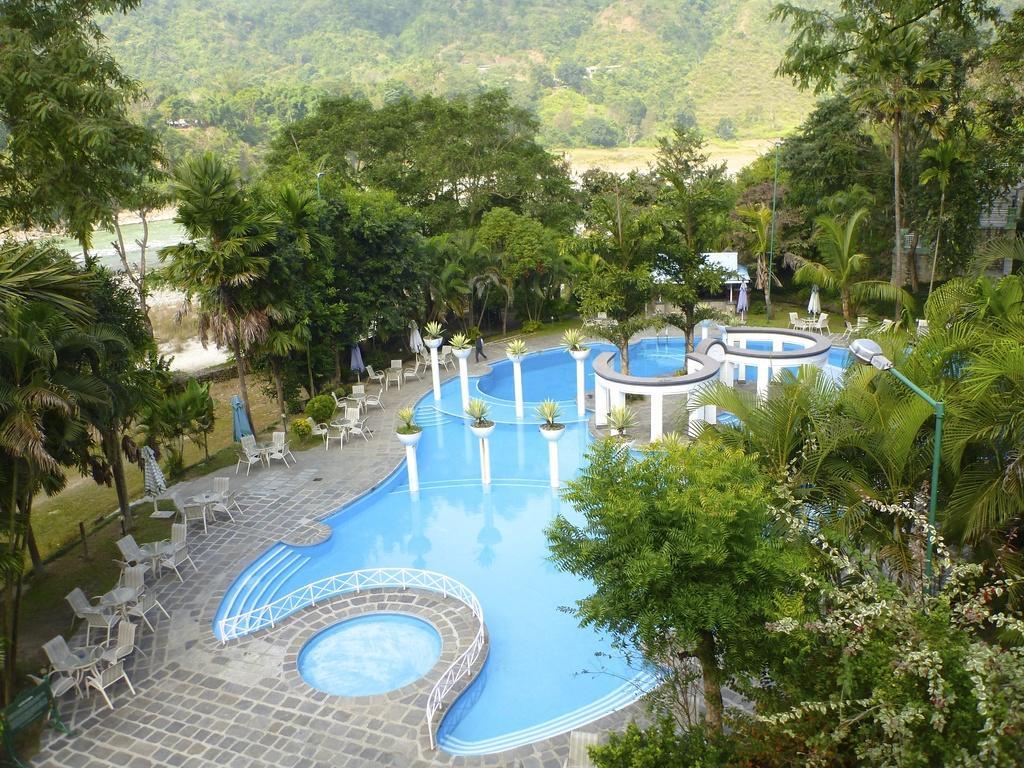Describe this image in one or two sentences. In this picture we can observe a swimming pool. There are some plants and chairs. We can observe some trees. In the background there is a hill. 